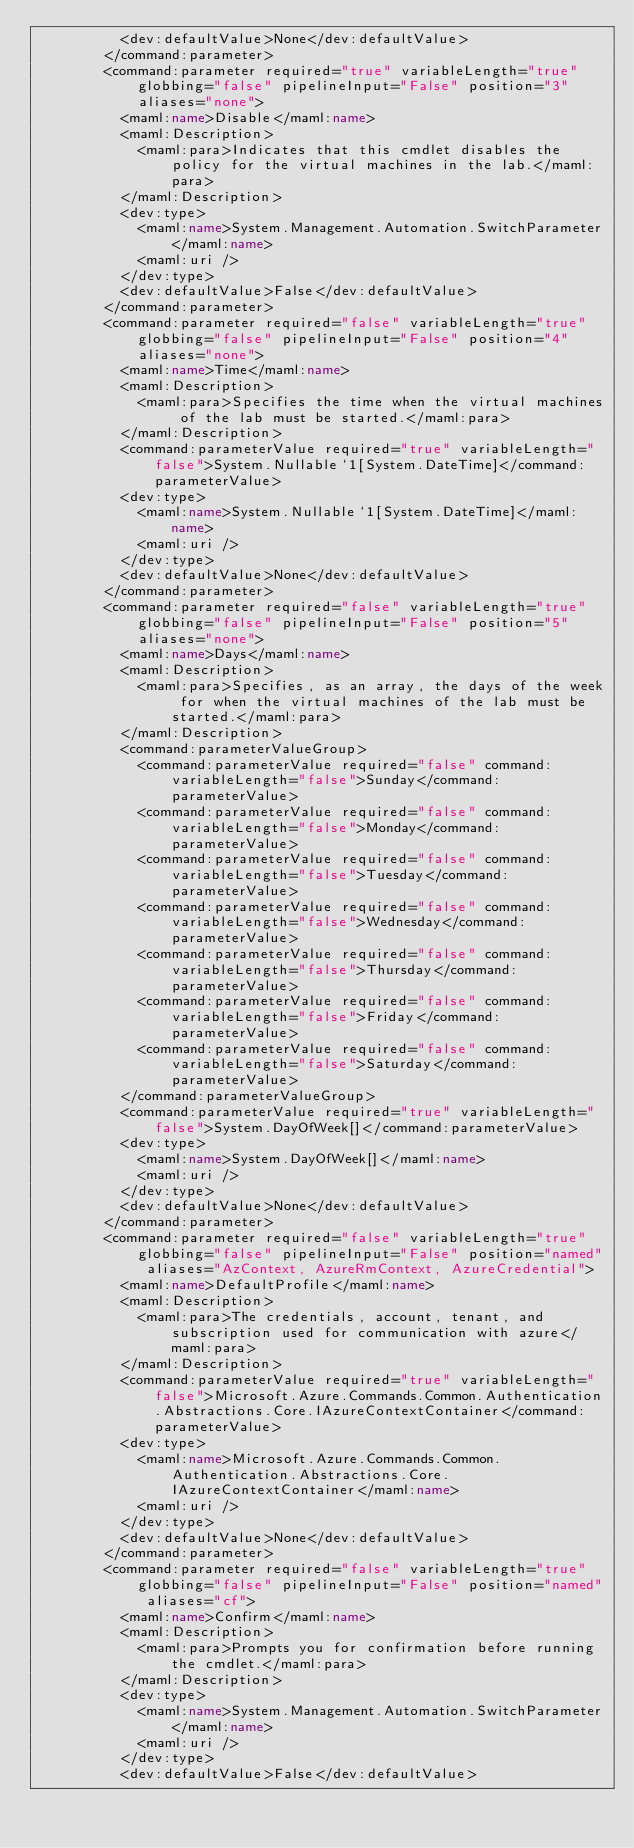<code> <loc_0><loc_0><loc_500><loc_500><_XML_>          <dev:defaultValue>None</dev:defaultValue>
        </command:parameter>
        <command:parameter required="true" variableLength="true" globbing="false" pipelineInput="False" position="3" aliases="none">
          <maml:name>Disable</maml:name>
          <maml:Description>
            <maml:para>Indicates that this cmdlet disables the policy for the virtual machines in the lab.</maml:para>
          </maml:Description>
          <dev:type>
            <maml:name>System.Management.Automation.SwitchParameter</maml:name>
            <maml:uri />
          </dev:type>
          <dev:defaultValue>False</dev:defaultValue>
        </command:parameter>
        <command:parameter required="false" variableLength="true" globbing="false" pipelineInput="False" position="4" aliases="none">
          <maml:name>Time</maml:name>
          <maml:Description>
            <maml:para>Specifies the time when the virtual machines of the lab must be started.</maml:para>
          </maml:Description>
          <command:parameterValue required="true" variableLength="false">System.Nullable`1[System.DateTime]</command:parameterValue>
          <dev:type>
            <maml:name>System.Nullable`1[System.DateTime]</maml:name>
            <maml:uri />
          </dev:type>
          <dev:defaultValue>None</dev:defaultValue>
        </command:parameter>
        <command:parameter required="false" variableLength="true" globbing="false" pipelineInput="False" position="5" aliases="none">
          <maml:name>Days</maml:name>
          <maml:Description>
            <maml:para>Specifies, as an array, the days of the week for when the virtual machines of the lab must be started.</maml:para>
          </maml:Description>
          <command:parameterValueGroup>
            <command:parameterValue required="false" command:variableLength="false">Sunday</command:parameterValue>
            <command:parameterValue required="false" command:variableLength="false">Monday</command:parameterValue>
            <command:parameterValue required="false" command:variableLength="false">Tuesday</command:parameterValue>
            <command:parameterValue required="false" command:variableLength="false">Wednesday</command:parameterValue>
            <command:parameterValue required="false" command:variableLength="false">Thursday</command:parameterValue>
            <command:parameterValue required="false" command:variableLength="false">Friday</command:parameterValue>
            <command:parameterValue required="false" command:variableLength="false">Saturday</command:parameterValue>
          </command:parameterValueGroup>
          <command:parameterValue required="true" variableLength="false">System.DayOfWeek[]</command:parameterValue>
          <dev:type>
            <maml:name>System.DayOfWeek[]</maml:name>
            <maml:uri />
          </dev:type>
          <dev:defaultValue>None</dev:defaultValue>
        </command:parameter>
        <command:parameter required="false" variableLength="true" globbing="false" pipelineInput="False" position="named" aliases="AzContext, AzureRmContext, AzureCredential">
          <maml:name>DefaultProfile</maml:name>
          <maml:Description>
            <maml:para>The credentials, account, tenant, and subscription used for communication with azure</maml:para>
          </maml:Description>
          <command:parameterValue required="true" variableLength="false">Microsoft.Azure.Commands.Common.Authentication.Abstractions.Core.IAzureContextContainer</command:parameterValue>
          <dev:type>
            <maml:name>Microsoft.Azure.Commands.Common.Authentication.Abstractions.Core.IAzureContextContainer</maml:name>
            <maml:uri />
          </dev:type>
          <dev:defaultValue>None</dev:defaultValue>
        </command:parameter>
        <command:parameter required="false" variableLength="true" globbing="false" pipelineInput="False" position="named" aliases="cf">
          <maml:name>Confirm</maml:name>
          <maml:Description>
            <maml:para>Prompts you for confirmation before running the cmdlet.</maml:para>
          </maml:Description>
          <dev:type>
            <maml:name>System.Management.Automation.SwitchParameter</maml:name>
            <maml:uri />
          </dev:type>
          <dev:defaultValue>False</dev:defaultValue></code> 